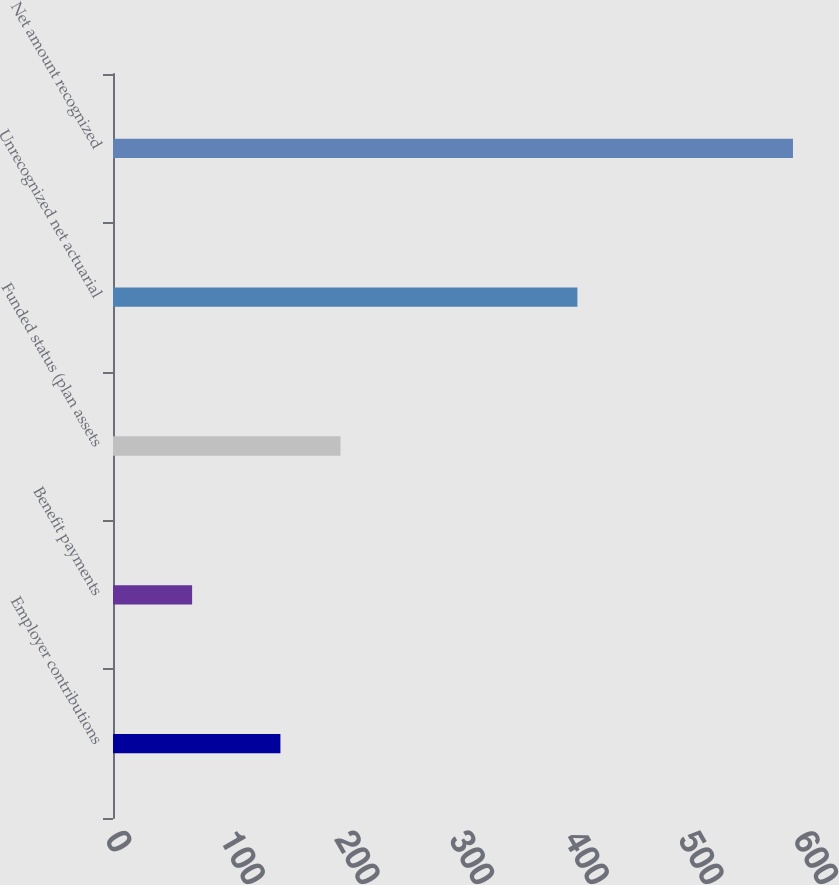<chart> <loc_0><loc_0><loc_500><loc_500><bar_chart><fcel>Employer contributions<fcel>Benefit payments<fcel>Funded status (plan assets<fcel>Unrecognized net actuarial<fcel>Net amount recognized<nl><fcel>146<fcel>69<fcel>198.4<fcel>405<fcel>593<nl></chart> 